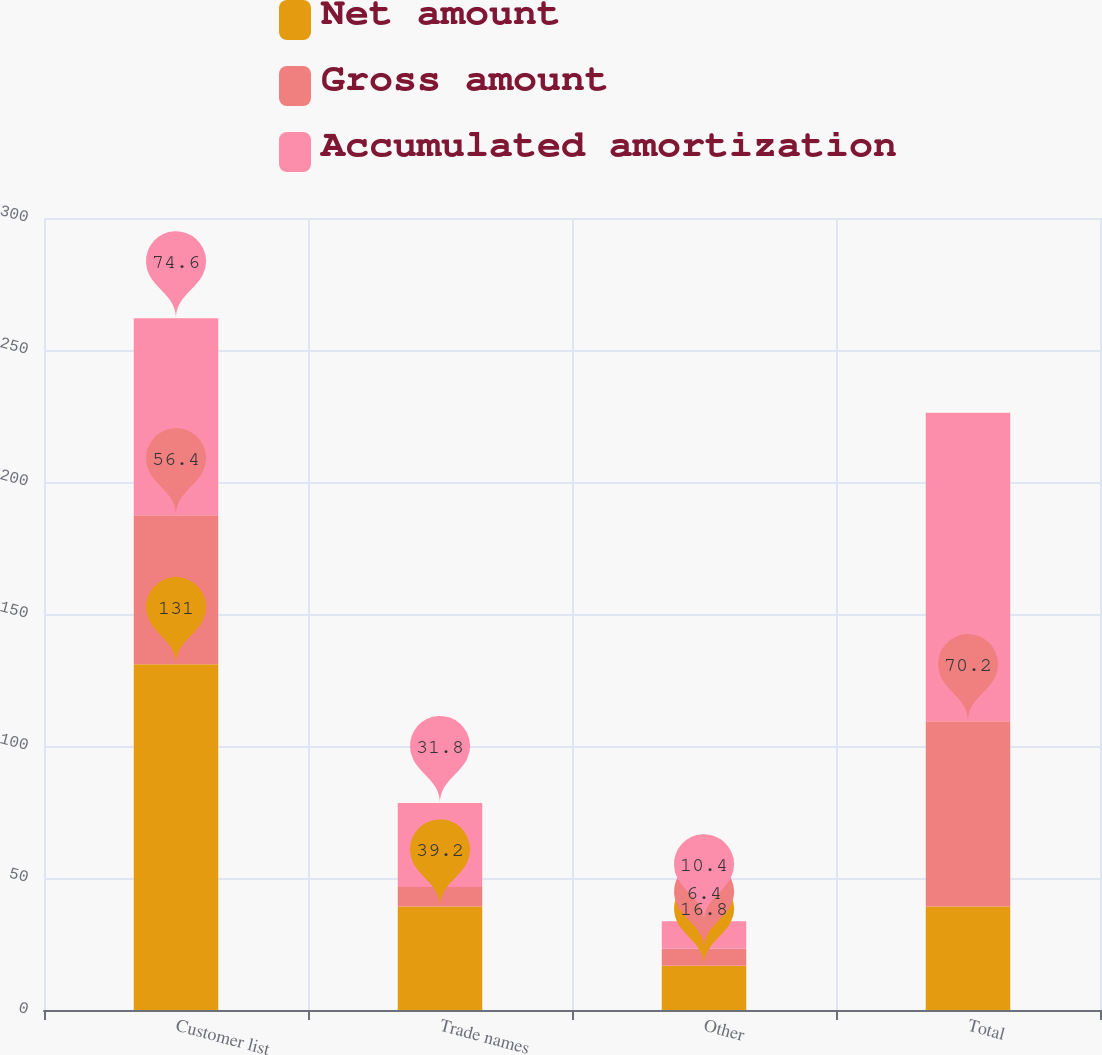Convert chart to OTSL. <chart><loc_0><loc_0><loc_500><loc_500><stacked_bar_chart><ecel><fcel>Customer list<fcel>Trade names<fcel>Other<fcel>Total<nl><fcel>Net amount<fcel>131<fcel>39.2<fcel>16.8<fcel>39.2<nl><fcel>Gross amount<fcel>56.4<fcel>7.4<fcel>6.4<fcel>70.2<nl><fcel>Accumulated amortization<fcel>74.6<fcel>31.8<fcel>10.4<fcel>116.8<nl></chart> 